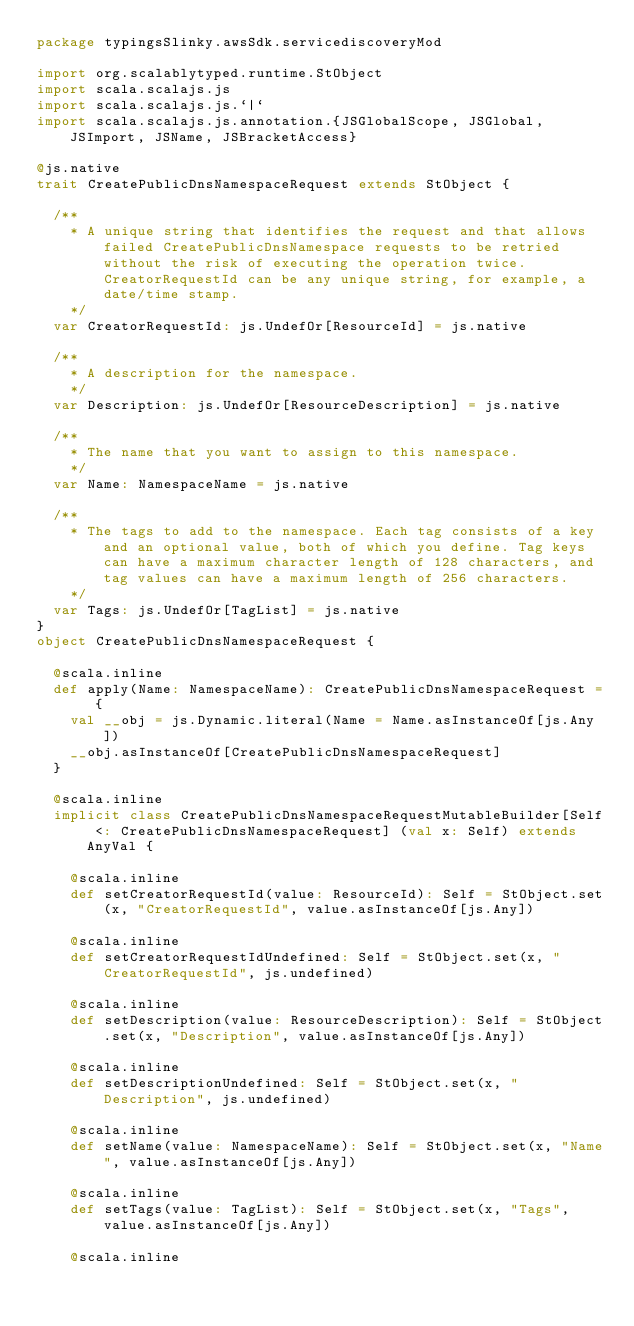Convert code to text. <code><loc_0><loc_0><loc_500><loc_500><_Scala_>package typingsSlinky.awsSdk.servicediscoveryMod

import org.scalablytyped.runtime.StObject
import scala.scalajs.js
import scala.scalajs.js.`|`
import scala.scalajs.js.annotation.{JSGlobalScope, JSGlobal, JSImport, JSName, JSBracketAccess}

@js.native
trait CreatePublicDnsNamespaceRequest extends StObject {
  
  /**
    * A unique string that identifies the request and that allows failed CreatePublicDnsNamespace requests to be retried without the risk of executing the operation twice. CreatorRequestId can be any unique string, for example, a date/time stamp.
    */
  var CreatorRequestId: js.UndefOr[ResourceId] = js.native
  
  /**
    * A description for the namespace.
    */
  var Description: js.UndefOr[ResourceDescription] = js.native
  
  /**
    * The name that you want to assign to this namespace.
    */
  var Name: NamespaceName = js.native
  
  /**
    * The tags to add to the namespace. Each tag consists of a key and an optional value, both of which you define. Tag keys can have a maximum character length of 128 characters, and tag values can have a maximum length of 256 characters.
    */
  var Tags: js.UndefOr[TagList] = js.native
}
object CreatePublicDnsNamespaceRequest {
  
  @scala.inline
  def apply(Name: NamespaceName): CreatePublicDnsNamespaceRequest = {
    val __obj = js.Dynamic.literal(Name = Name.asInstanceOf[js.Any])
    __obj.asInstanceOf[CreatePublicDnsNamespaceRequest]
  }
  
  @scala.inline
  implicit class CreatePublicDnsNamespaceRequestMutableBuilder[Self <: CreatePublicDnsNamespaceRequest] (val x: Self) extends AnyVal {
    
    @scala.inline
    def setCreatorRequestId(value: ResourceId): Self = StObject.set(x, "CreatorRequestId", value.asInstanceOf[js.Any])
    
    @scala.inline
    def setCreatorRequestIdUndefined: Self = StObject.set(x, "CreatorRequestId", js.undefined)
    
    @scala.inline
    def setDescription(value: ResourceDescription): Self = StObject.set(x, "Description", value.asInstanceOf[js.Any])
    
    @scala.inline
    def setDescriptionUndefined: Self = StObject.set(x, "Description", js.undefined)
    
    @scala.inline
    def setName(value: NamespaceName): Self = StObject.set(x, "Name", value.asInstanceOf[js.Any])
    
    @scala.inline
    def setTags(value: TagList): Self = StObject.set(x, "Tags", value.asInstanceOf[js.Any])
    
    @scala.inline</code> 